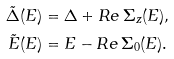Convert formula to latex. <formula><loc_0><loc_0><loc_500><loc_500>\tilde { \Delta } ( E ) & = \Delta + R e \, \Sigma _ { z } ( E ) , \\ \tilde { E } ( E ) & = E - R e \, \Sigma _ { 0 } ( E ) .</formula> 